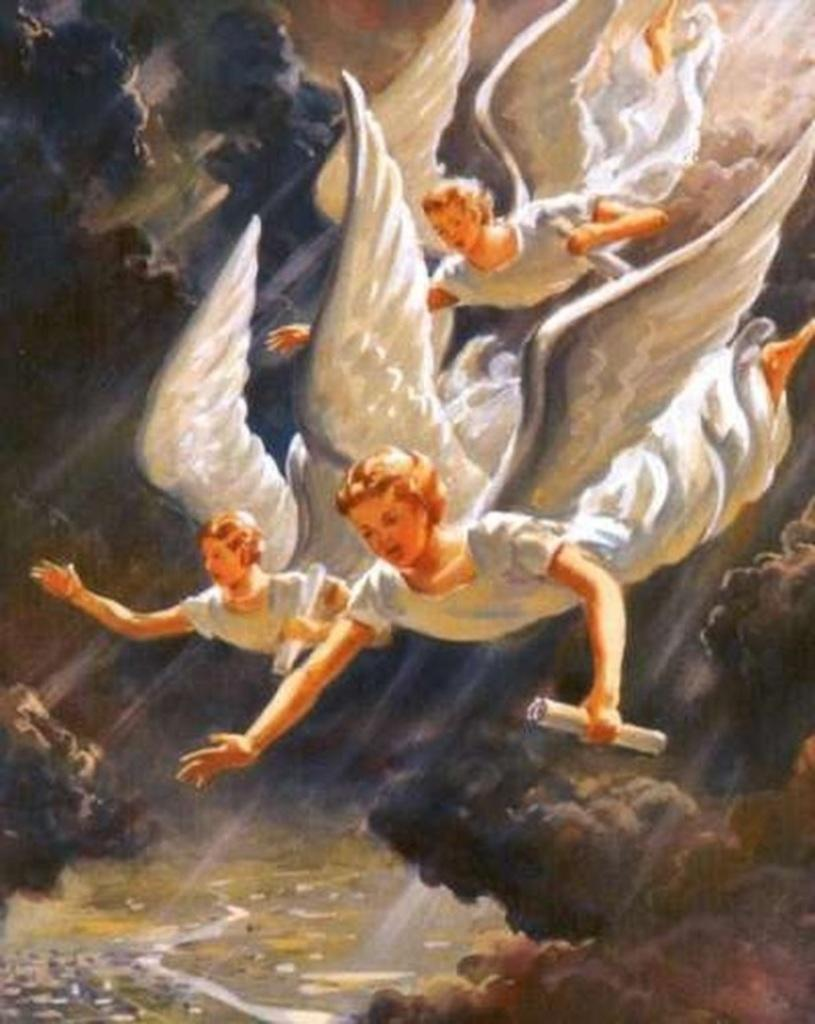What type of artwork is depicted in the image? The image is a painting. What subjects are featured in the painting? There is a group of angels in the painting. What action are the angels performing in the painting? The angels are falling from the sky in the painting. What type of yard can be seen in the painting? There is no yard present in the painting; it features a group of angels falling from the sky. Can you tell me how many fish are swimming in the painting? There are no fish present in the painting; it features a group of angels falling from the sky. 